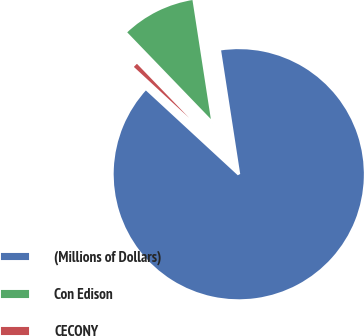<chart> <loc_0><loc_0><loc_500><loc_500><pie_chart><fcel>(Millions of Dollars)<fcel>Con Edison<fcel>CECONY<nl><fcel>89.3%<fcel>9.77%<fcel>0.93%<nl></chart> 